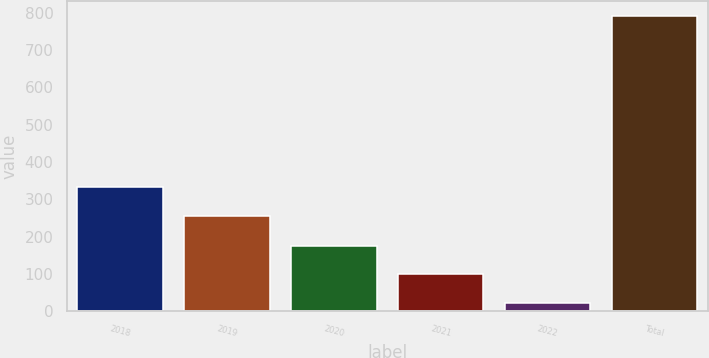Convert chart to OTSL. <chart><loc_0><loc_0><loc_500><loc_500><bar_chart><fcel>2018<fcel>2019<fcel>2020<fcel>2021<fcel>2022<fcel>Total<nl><fcel>332<fcel>255<fcel>176<fcel>99<fcel>22<fcel>792<nl></chart> 